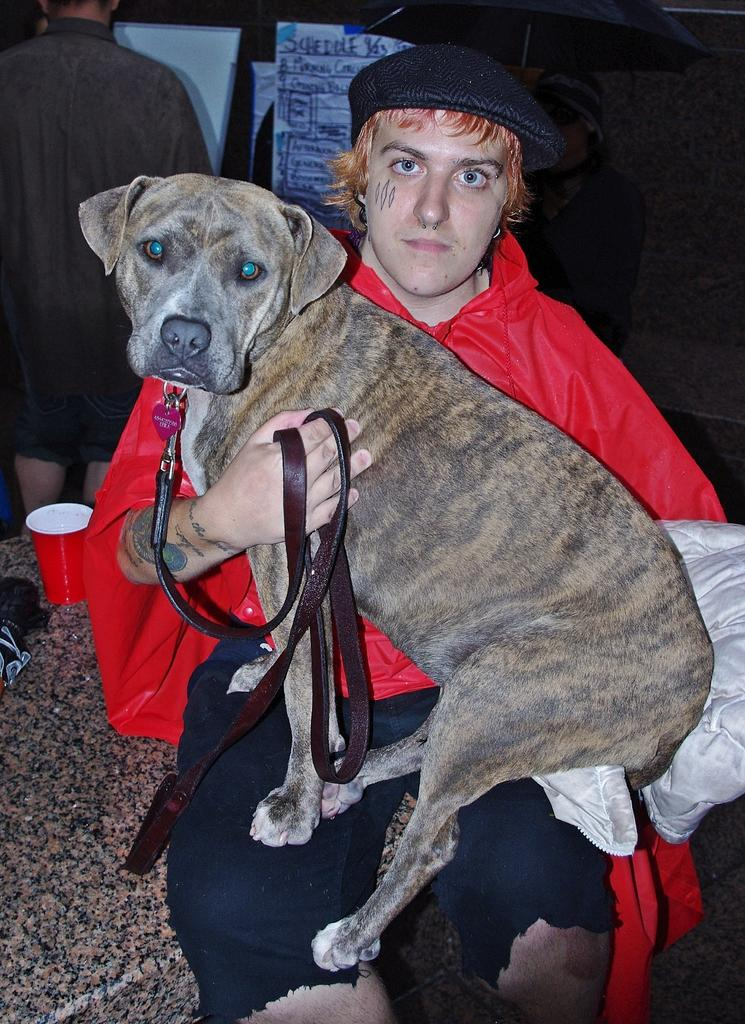What is the person in the image doing? The person is sitting and watching a dog in the image. Can you describe the person's hand in the image? The person's hand is visible in the image. What is located near the person in the image? There is a glass near the person in the image. What type of fowl can be seen flying over the van in the image? There is no van or fowl present in the image. How many rails are visible in the image? There are no rails visible in the image. 